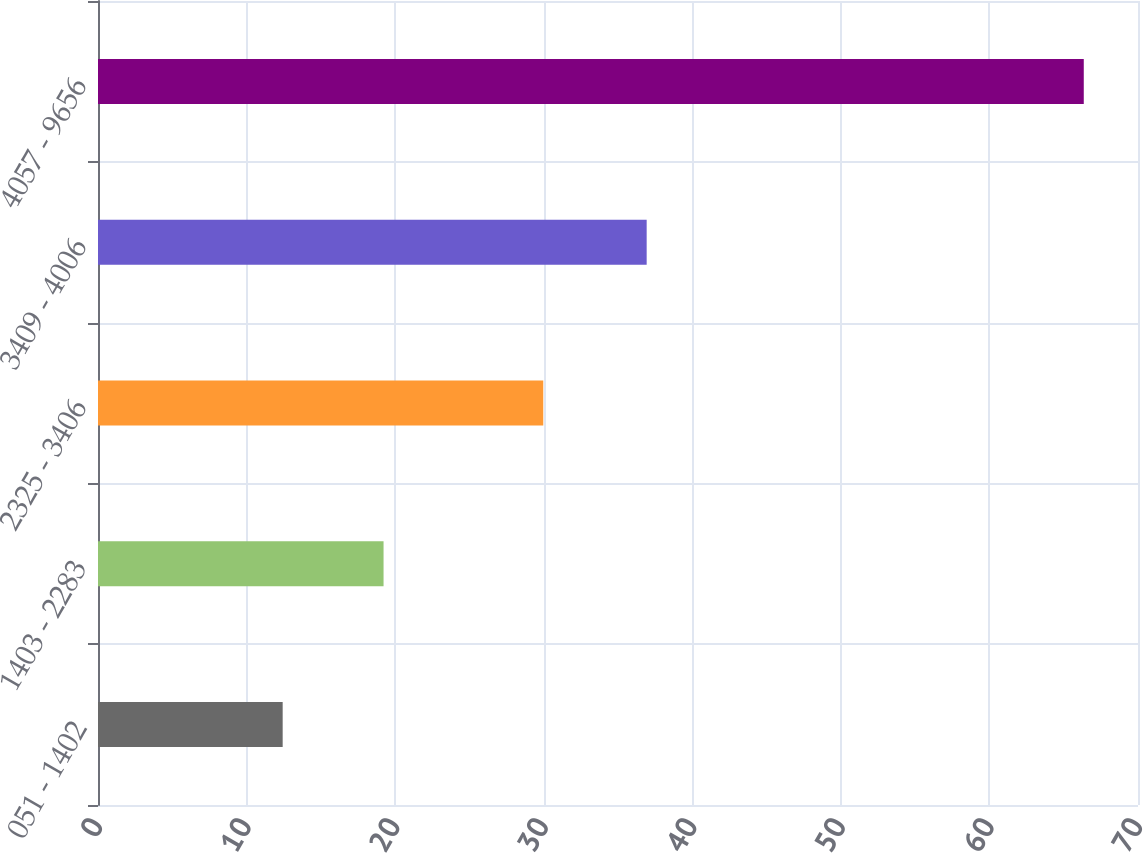Convert chart. <chart><loc_0><loc_0><loc_500><loc_500><bar_chart><fcel>051 - 1402<fcel>1403 - 2283<fcel>2325 - 3406<fcel>3409 - 4006<fcel>4057 - 9656<nl><fcel>12.43<fcel>19.22<fcel>29.97<fcel>36.93<fcel>66.35<nl></chart> 